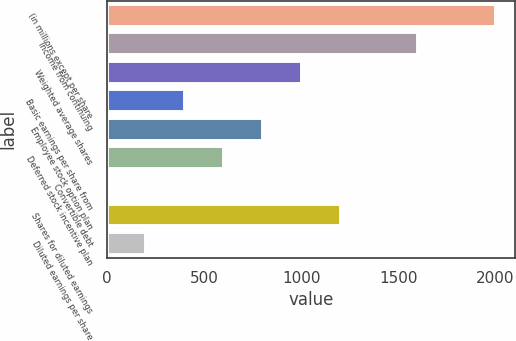Convert chart to OTSL. <chart><loc_0><loc_0><loc_500><loc_500><bar_chart><fcel>(in millions except per share<fcel>Income from continuing<fcel>Weighted average shares<fcel>Basic earnings per share from<fcel>Employee stock option plan<fcel>Deferred stock incentive plan<fcel>Convertible debt<fcel>Shares for diluted earnings<fcel>Diluted earnings per share<nl><fcel>2003<fcel>1602.58<fcel>1001.95<fcel>401.32<fcel>801.74<fcel>601.53<fcel>0.9<fcel>1202.16<fcel>201.11<nl></chart> 